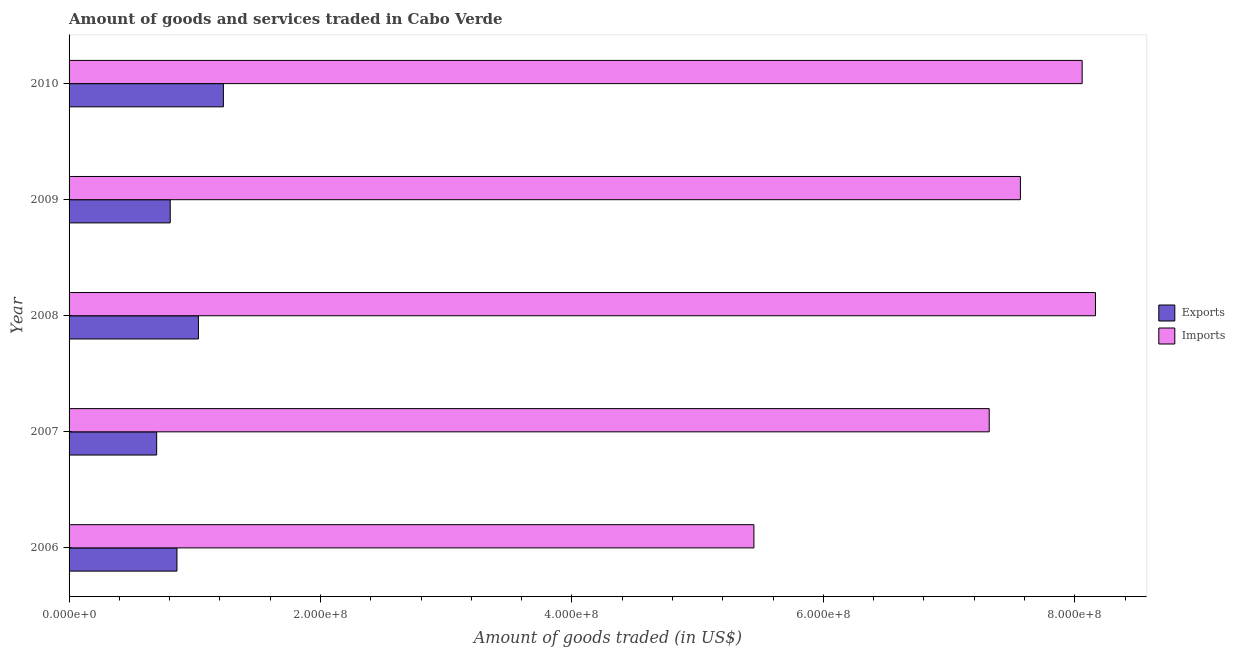How many different coloured bars are there?
Give a very brief answer. 2. How many groups of bars are there?
Provide a succinct answer. 5. Are the number of bars on each tick of the Y-axis equal?
Your answer should be very brief. Yes. How many bars are there on the 5th tick from the top?
Make the answer very short. 2. What is the amount of goods imported in 2006?
Ensure brevity in your answer.  5.45e+08. Across all years, what is the maximum amount of goods exported?
Make the answer very short. 1.23e+08. Across all years, what is the minimum amount of goods imported?
Offer a very short reply. 5.45e+08. In which year was the amount of goods exported maximum?
Give a very brief answer. 2010. In which year was the amount of goods imported minimum?
Keep it short and to the point. 2006. What is the total amount of goods imported in the graph?
Offer a very short reply. 3.66e+09. What is the difference between the amount of goods imported in 2008 and that in 2009?
Offer a terse response. 5.97e+07. What is the difference between the amount of goods imported in 2006 and the amount of goods exported in 2007?
Your answer should be very brief. 4.75e+08. What is the average amount of goods imported per year?
Make the answer very short. 7.31e+08. In the year 2006, what is the difference between the amount of goods imported and amount of goods exported?
Your response must be concise. 4.59e+08. What is the ratio of the amount of goods exported in 2006 to that in 2010?
Offer a very short reply. 0.7. Is the amount of goods exported in 2008 less than that in 2009?
Your response must be concise. No. Is the difference between the amount of goods exported in 2007 and 2008 greater than the difference between the amount of goods imported in 2007 and 2008?
Offer a terse response. Yes. What is the difference between the highest and the second highest amount of goods imported?
Offer a terse response. 1.06e+07. What is the difference between the highest and the lowest amount of goods exported?
Make the answer very short. 5.31e+07. What does the 2nd bar from the top in 2010 represents?
Keep it short and to the point. Exports. What does the 1st bar from the bottom in 2010 represents?
Offer a very short reply. Exports. How many years are there in the graph?
Your response must be concise. 5. What is the difference between two consecutive major ticks on the X-axis?
Make the answer very short. 2.00e+08. Are the values on the major ticks of X-axis written in scientific E-notation?
Your response must be concise. Yes. Does the graph contain grids?
Provide a succinct answer. No. Where does the legend appear in the graph?
Ensure brevity in your answer.  Center right. What is the title of the graph?
Offer a terse response. Amount of goods and services traded in Cabo Verde. What is the label or title of the X-axis?
Keep it short and to the point. Amount of goods traded (in US$). What is the label or title of the Y-axis?
Your answer should be very brief. Year. What is the Amount of goods traded (in US$) of Exports in 2006?
Your answer should be compact. 8.58e+07. What is the Amount of goods traded (in US$) of Imports in 2006?
Keep it short and to the point. 5.45e+08. What is the Amount of goods traded (in US$) in Exports in 2007?
Your answer should be very brief. 6.97e+07. What is the Amount of goods traded (in US$) in Imports in 2007?
Offer a terse response. 7.32e+08. What is the Amount of goods traded (in US$) of Exports in 2008?
Keep it short and to the point. 1.03e+08. What is the Amount of goods traded (in US$) of Imports in 2008?
Ensure brevity in your answer.  8.16e+08. What is the Amount of goods traded (in US$) in Exports in 2009?
Provide a succinct answer. 8.05e+07. What is the Amount of goods traded (in US$) of Imports in 2009?
Give a very brief answer. 7.57e+08. What is the Amount of goods traded (in US$) of Exports in 2010?
Provide a succinct answer. 1.23e+08. What is the Amount of goods traded (in US$) in Imports in 2010?
Provide a short and direct response. 8.06e+08. Across all years, what is the maximum Amount of goods traded (in US$) in Exports?
Offer a terse response. 1.23e+08. Across all years, what is the maximum Amount of goods traded (in US$) of Imports?
Offer a very short reply. 8.16e+08. Across all years, what is the minimum Amount of goods traded (in US$) in Exports?
Keep it short and to the point. 6.97e+07. Across all years, what is the minimum Amount of goods traded (in US$) in Imports?
Your response must be concise. 5.45e+08. What is the total Amount of goods traded (in US$) of Exports in the graph?
Make the answer very short. 4.62e+08. What is the total Amount of goods traded (in US$) of Imports in the graph?
Your answer should be compact. 3.66e+09. What is the difference between the Amount of goods traded (in US$) in Exports in 2006 and that in 2007?
Give a very brief answer. 1.61e+07. What is the difference between the Amount of goods traded (in US$) of Imports in 2006 and that in 2007?
Offer a very short reply. -1.87e+08. What is the difference between the Amount of goods traded (in US$) in Exports in 2006 and that in 2008?
Provide a short and direct response. -1.71e+07. What is the difference between the Amount of goods traded (in US$) of Imports in 2006 and that in 2008?
Make the answer very short. -2.72e+08. What is the difference between the Amount of goods traded (in US$) in Exports in 2006 and that in 2009?
Provide a succinct answer. 5.36e+06. What is the difference between the Amount of goods traded (in US$) in Imports in 2006 and that in 2009?
Give a very brief answer. -2.12e+08. What is the difference between the Amount of goods traded (in US$) of Exports in 2006 and that in 2010?
Offer a very short reply. -3.69e+07. What is the difference between the Amount of goods traded (in US$) of Imports in 2006 and that in 2010?
Your answer should be compact. -2.61e+08. What is the difference between the Amount of goods traded (in US$) in Exports in 2007 and that in 2008?
Make the answer very short. -3.32e+07. What is the difference between the Amount of goods traded (in US$) in Imports in 2007 and that in 2008?
Offer a very short reply. -8.45e+07. What is the difference between the Amount of goods traded (in US$) of Exports in 2007 and that in 2009?
Offer a very short reply. -1.08e+07. What is the difference between the Amount of goods traded (in US$) of Imports in 2007 and that in 2009?
Make the answer very short. -2.48e+07. What is the difference between the Amount of goods traded (in US$) in Exports in 2007 and that in 2010?
Keep it short and to the point. -5.31e+07. What is the difference between the Amount of goods traded (in US$) of Imports in 2007 and that in 2010?
Make the answer very short. -7.39e+07. What is the difference between the Amount of goods traded (in US$) of Exports in 2008 and that in 2009?
Offer a very short reply. 2.24e+07. What is the difference between the Amount of goods traded (in US$) in Imports in 2008 and that in 2009?
Provide a short and direct response. 5.97e+07. What is the difference between the Amount of goods traded (in US$) of Exports in 2008 and that in 2010?
Your answer should be very brief. -1.99e+07. What is the difference between the Amount of goods traded (in US$) of Imports in 2008 and that in 2010?
Provide a short and direct response. 1.06e+07. What is the difference between the Amount of goods traded (in US$) in Exports in 2009 and that in 2010?
Your answer should be compact. -4.23e+07. What is the difference between the Amount of goods traded (in US$) of Imports in 2009 and that in 2010?
Your answer should be very brief. -4.91e+07. What is the difference between the Amount of goods traded (in US$) in Exports in 2006 and the Amount of goods traded (in US$) in Imports in 2007?
Provide a short and direct response. -6.46e+08. What is the difference between the Amount of goods traded (in US$) of Exports in 2006 and the Amount of goods traded (in US$) of Imports in 2008?
Your response must be concise. -7.31e+08. What is the difference between the Amount of goods traded (in US$) of Exports in 2006 and the Amount of goods traded (in US$) of Imports in 2009?
Offer a terse response. -6.71e+08. What is the difference between the Amount of goods traded (in US$) of Exports in 2006 and the Amount of goods traded (in US$) of Imports in 2010?
Provide a succinct answer. -7.20e+08. What is the difference between the Amount of goods traded (in US$) in Exports in 2007 and the Amount of goods traded (in US$) in Imports in 2008?
Give a very brief answer. -7.47e+08. What is the difference between the Amount of goods traded (in US$) of Exports in 2007 and the Amount of goods traded (in US$) of Imports in 2009?
Your response must be concise. -6.87e+08. What is the difference between the Amount of goods traded (in US$) in Exports in 2007 and the Amount of goods traded (in US$) in Imports in 2010?
Offer a very short reply. -7.36e+08. What is the difference between the Amount of goods traded (in US$) in Exports in 2008 and the Amount of goods traded (in US$) in Imports in 2009?
Your response must be concise. -6.54e+08. What is the difference between the Amount of goods traded (in US$) in Exports in 2008 and the Amount of goods traded (in US$) in Imports in 2010?
Your answer should be compact. -7.03e+08. What is the difference between the Amount of goods traded (in US$) of Exports in 2009 and the Amount of goods traded (in US$) of Imports in 2010?
Keep it short and to the point. -7.25e+08. What is the average Amount of goods traded (in US$) in Exports per year?
Offer a terse response. 9.23e+07. What is the average Amount of goods traded (in US$) of Imports per year?
Your answer should be compact. 7.31e+08. In the year 2006, what is the difference between the Amount of goods traded (in US$) of Exports and Amount of goods traded (in US$) of Imports?
Make the answer very short. -4.59e+08. In the year 2007, what is the difference between the Amount of goods traded (in US$) in Exports and Amount of goods traded (in US$) in Imports?
Keep it short and to the point. -6.62e+08. In the year 2008, what is the difference between the Amount of goods traded (in US$) in Exports and Amount of goods traded (in US$) in Imports?
Your response must be concise. -7.14e+08. In the year 2009, what is the difference between the Amount of goods traded (in US$) in Exports and Amount of goods traded (in US$) in Imports?
Offer a terse response. -6.76e+08. In the year 2010, what is the difference between the Amount of goods traded (in US$) in Exports and Amount of goods traded (in US$) in Imports?
Your response must be concise. -6.83e+08. What is the ratio of the Amount of goods traded (in US$) in Exports in 2006 to that in 2007?
Give a very brief answer. 1.23. What is the ratio of the Amount of goods traded (in US$) in Imports in 2006 to that in 2007?
Provide a short and direct response. 0.74. What is the ratio of the Amount of goods traded (in US$) of Exports in 2006 to that in 2008?
Ensure brevity in your answer.  0.83. What is the ratio of the Amount of goods traded (in US$) in Imports in 2006 to that in 2008?
Offer a very short reply. 0.67. What is the ratio of the Amount of goods traded (in US$) in Exports in 2006 to that in 2009?
Your answer should be compact. 1.07. What is the ratio of the Amount of goods traded (in US$) of Imports in 2006 to that in 2009?
Keep it short and to the point. 0.72. What is the ratio of the Amount of goods traded (in US$) in Exports in 2006 to that in 2010?
Make the answer very short. 0.7. What is the ratio of the Amount of goods traded (in US$) of Imports in 2006 to that in 2010?
Offer a very short reply. 0.68. What is the ratio of the Amount of goods traded (in US$) in Exports in 2007 to that in 2008?
Your answer should be very brief. 0.68. What is the ratio of the Amount of goods traded (in US$) of Imports in 2007 to that in 2008?
Make the answer very short. 0.9. What is the ratio of the Amount of goods traded (in US$) in Exports in 2007 to that in 2009?
Offer a very short reply. 0.87. What is the ratio of the Amount of goods traded (in US$) of Imports in 2007 to that in 2009?
Keep it short and to the point. 0.97. What is the ratio of the Amount of goods traded (in US$) of Exports in 2007 to that in 2010?
Offer a terse response. 0.57. What is the ratio of the Amount of goods traded (in US$) of Imports in 2007 to that in 2010?
Your answer should be very brief. 0.91. What is the ratio of the Amount of goods traded (in US$) of Exports in 2008 to that in 2009?
Ensure brevity in your answer.  1.28. What is the ratio of the Amount of goods traded (in US$) of Imports in 2008 to that in 2009?
Provide a succinct answer. 1.08. What is the ratio of the Amount of goods traded (in US$) of Exports in 2008 to that in 2010?
Your answer should be very brief. 0.84. What is the ratio of the Amount of goods traded (in US$) in Imports in 2008 to that in 2010?
Keep it short and to the point. 1.01. What is the ratio of the Amount of goods traded (in US$) of Exports in 2009 to that in 2010?
Provide a succinct answer. 0.66. What is the ratio of the Amount of goods traded (in US$) in Imports in 2009 to that in 2010?
Provide a short and direct response. 0.94. What is the difference between the highest and the second highest Amount of goods traded (in US$) in Exports?
Ensure brevity in your answer.  1.99e+07. What is the difference between the highest and the second highest Amount of goods traded (in US$) of Imports?
Your response must be concise. 1.06e+07. What is the difference between the highest and the lowest Amount of goods traded (in US$) of Exports?
Make the answer very short. 5.31e+07. What is the difference between the highest and the lowest Amount of goods traded (in US$) of Imports?
Your response must be concise. 2.72e+08. 